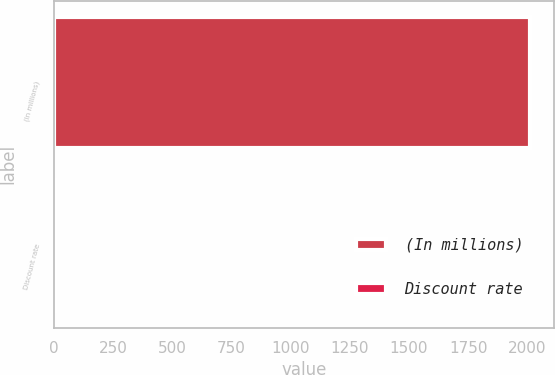Convert chart. <chart><loc_0><loc_0><loc_500><loc_500><bar_chart><fcel>(In millions)<fcel>Discount rate<nl><fcel>2011<fcel>5.25<nl></chart> 